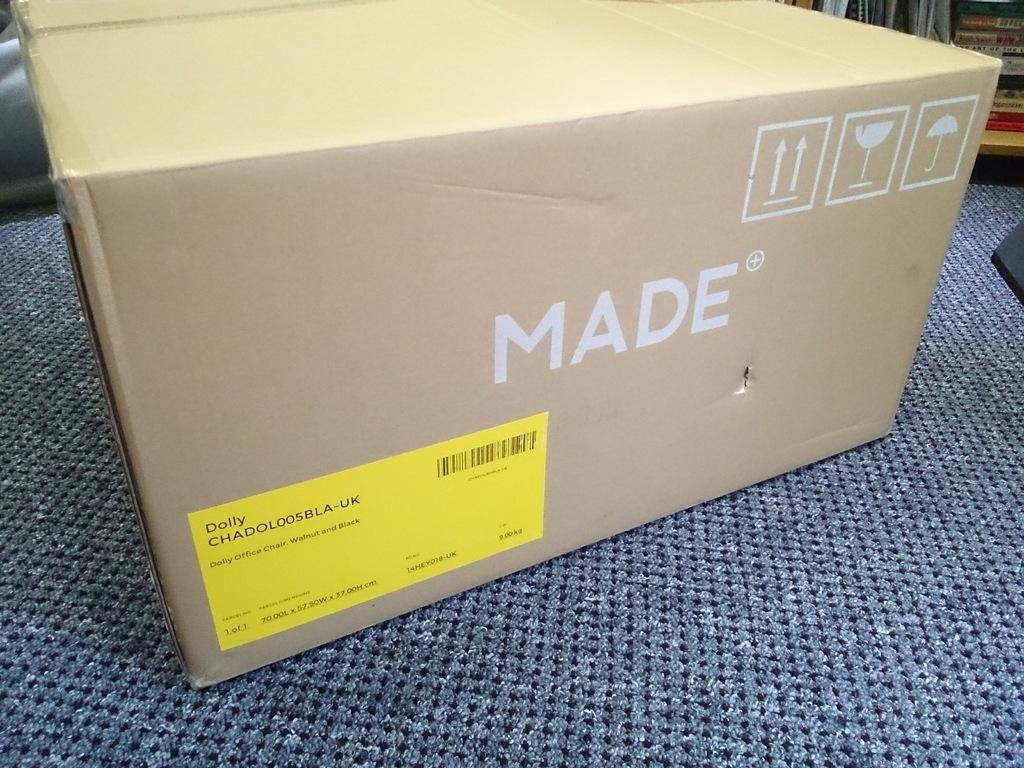<image>
Present a compact description of the photo's key features. a cardboard box on top of a blue carpet that is labeled 'made' 